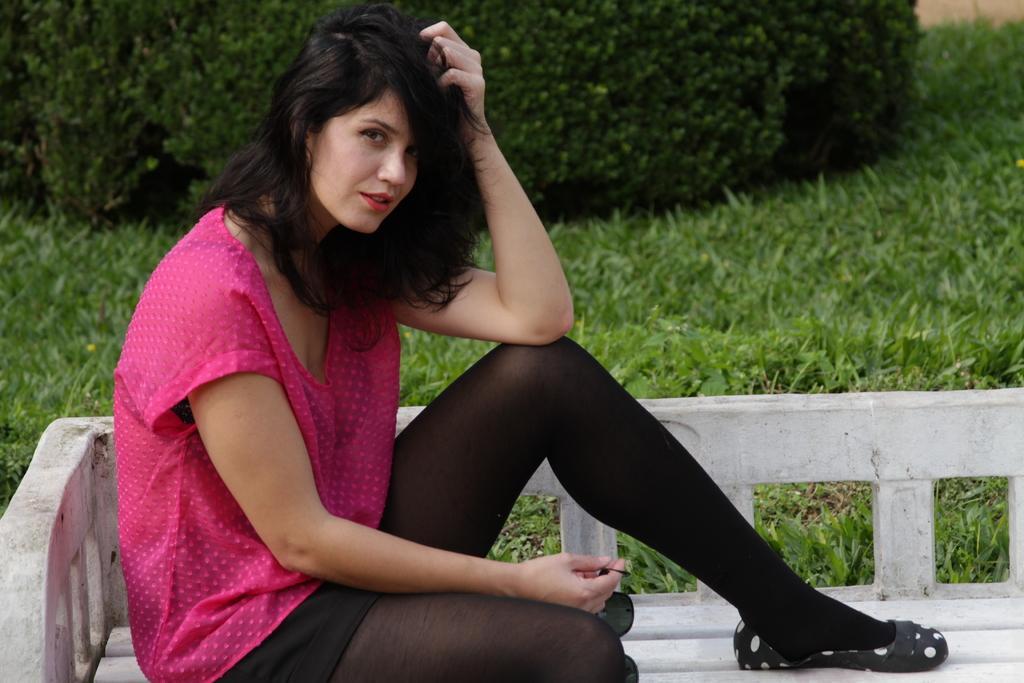Could you give a brief overview of what you see in this image? On the left side of this image I can see a woman wearing a pink color t-shirt, sitting on a bench, facing towards the right side and she is giving pose for the picture. In the background, I can see the grass and plants. 